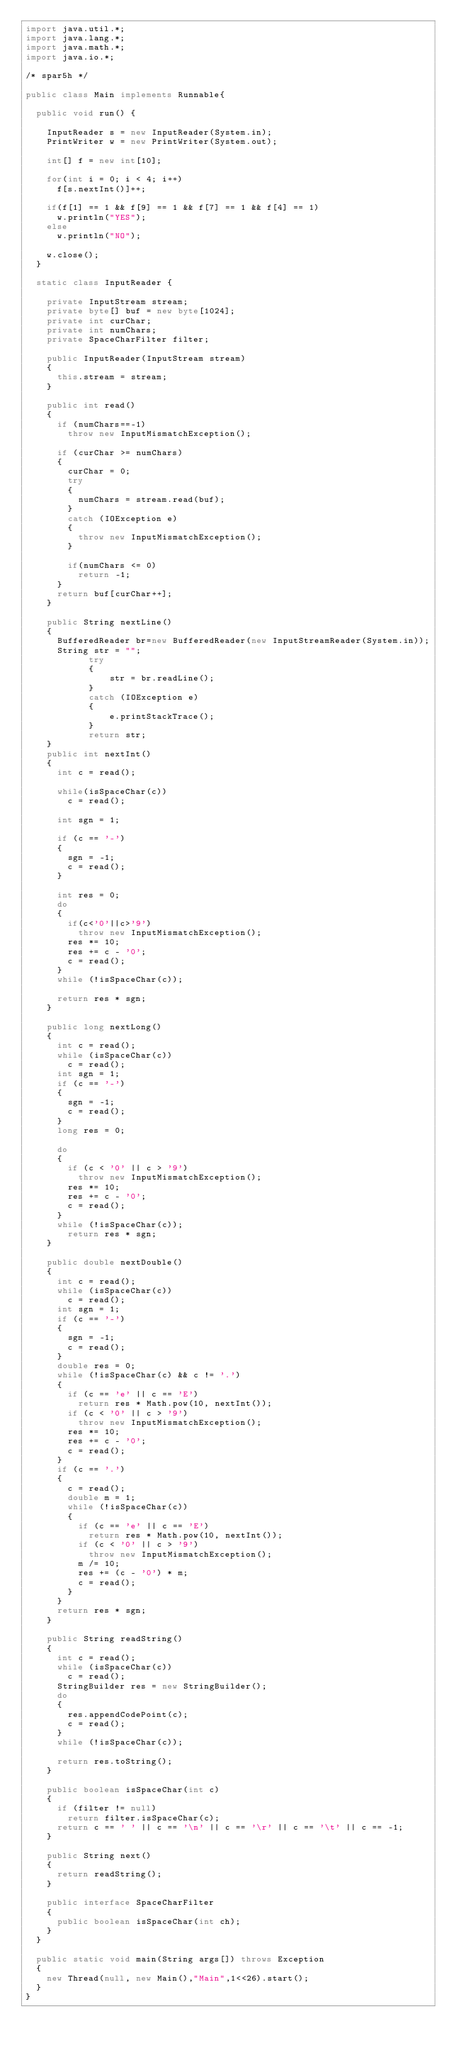Convert code to text. <code><loc_0><loc_0><loc_500><loc_500><_Java_>import java.util.*;
import java.lang.*;
import java.math.*;
import java.io.*;

/* spar5h */

public class Main implements Runnable{    
	
	public void run() {
		
		InputReader s = new InputReader(System.in);
		PrintWriter w = new PrintWriter(System.out);
		
		int[] f = new int[10];
		
		for(int i = 0; i < 4; i++)
			f[s.nextInt()]++;
		
		if(f[1] == 1 && f[9] == 1 && f[7] == 1 && f[4] == 1)
			w.println("YES");
		else
			w.println("NO");
		
		w.close();
	}
	
	static class InputReader {
		
		private InputStream stream;
		private byte[] buf = new byte[1024];
		private int curChar;
		private int numChars;
		private SpaceCharFilter filter;
		
		public InputReader(InputStream stream)
		{
			this.stream = stream;
		}
		
		public int read()
		{
			if (numChars==-1) 
				throw new InputMismatchException();
			
			if (curChar >= numChars)
			{
				curChar = 0;
				try 
				{
					numChars = stream.read(buf);
				}
				catch (IOException e)
				{
					throw new InputMismatchException();
				}
				
				if(numChars <= 0)				
					return -1;
			}
			return buf[curChar++];
		}
	 
		public String nextLine()
		{
			BufferedReader br=new BufferedReader(new InputStreamReader(System.in));
			String str = "";
            try
            {
                str = br.readLine();
            }
            catch (IOException e)
            {
                e.printStackTrace();
            }
            return str;
		}
		public int nextInt()
		{
			int c = read();
			
			while(isSpaceChar(c)) 
				c = read();
			
			int sgn = 1;
			
			if (c == '-') 
			{
				sgn = -1;
				c = read();
			}
			
			int res = 0;
			do 
			{
				if(c<'0'||c>'9') 
					throw new InputMismatchException();
				res *= 10;
				res += c - '0';
				c = read();
			}
			while (!isSpaceChar(c)); 
			
			return res * sgn;
		}
		
		public long nextLong() 
		{
			int c = read();
			while (isSpaceChar(c))
				c = read();
			int sgn = 1;
			if (c == '-') 
			{
				sgn = -1;
				c = read();
			}
			long res = 0;
			
			do 
			{
				if (c < '0' || c > '9')
					throw new InputMismatchException();
				res *= 10;
				res += c - '0';
				c = read();
			}
			while (!isSpaceChar(c));
				return res * sgn;
		}
		
		public double nextDouble() 
		{
			int c = read();
			while (isSpaceChar(c))
				c = read();
			int sgn = 1;
			if (c == '-') 
			{
				sgn = -1;
				c = read();
			}
			double res = 0;
			while (!isSpaceChar(c) && c != '.') 
			{
				if (c == 'e' || c == 'E')
					return res * Math.pow(10, nextInt());
				if (c < '0' || c > '9')
					throw new InputMismatchException();
				res *= 10;
				res += c - '0';
				c = read();
			}
			if (c == '.') 
			{
				c = read();
				double m = 1;
				while (!isSpaceChar(c)) 
				{
					if (c == 'e' || c == 'E')
						return res * Math.pow(10, nextInt());
					if (c < '0' || c > '9')
						throw new InputMismatchException();
					m /= 10;
					res += (c - '0') * m;
					c = read();
				}
			}
			return res * sgn;
		}
		
		public String readString() 
		{
			int c = read();
			while (isSpaceChar(c))
				c = read();
			StringBuilder res = new StringBuilder();
			do 
			{
				res.appendCodePoint(c);
				c = read();
			} 
			while (!isSpaceChar(c));
			
			return res.toString();
		}
	 
		public boolean isSpaceChar(int c) 
		{
			if (filter != null)
				return filter.isSpaceChar(c);
			return c == ' ' || c == '\n' || c == '\r' || c == '\t' || c == -1;
		}
	 
		public String next() 
		{
			return readString();
		}
		
		public interface SpaceCharFilter 
		{
			public boolean isSpaceChar(int ch);
		}
	}
    
	public static void main(String args[]) throws Exception
	{
		new Thread(null, new Main(),"Main",1<<26).start();
	}
}</code> 